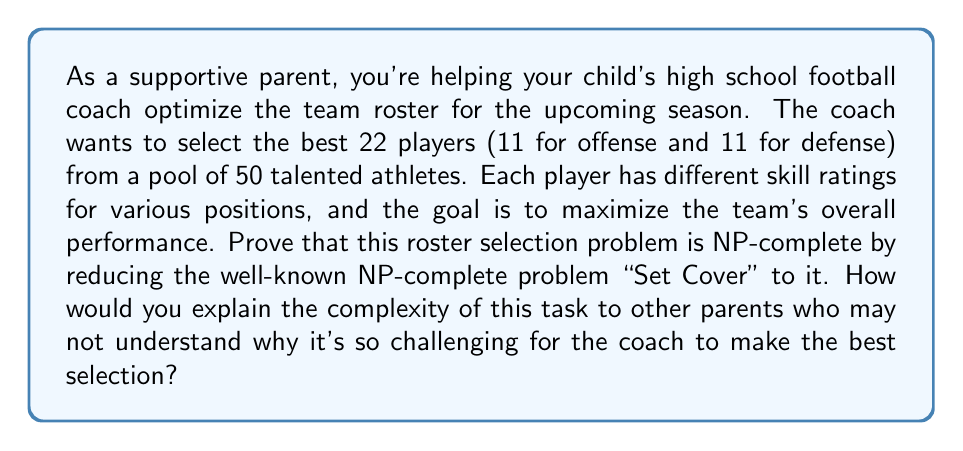Show me your answer to this math problem. To prove that the roster selection problem is NP-complete, we need to show that it's in NP and that a known NP-complete problem can be reduced to it. Let's break this down step-by-step:

1. Show that the problem is in NP:
   A problem is in NP if a proposed solution can be verified in polynomial time. In this case, given a roster selection, we can quickly check if it satisfies all constraints (22 players, 11 for offense and 11 for defense) and calculate the team's overall performance based on the players' skill ratings. This verification can be done in polynomial time.

2. Reduce the Set Cover problem to the roster selection problem:
   The Set Cover problem is known to be NP-complete. We'll show that any instance of Set Cover can be transformed into an instance of the roster selection problem.

   Set Cover problem: Given a universe $U = \{1, 2, ..., n\}$ and a collection of subsets $S = \{S_1, S_2, ..., S_m\}$ of $U$, find the minimum number of subsets from $S$ that cover all elements in $U$.

   Transformation:
   - For each element $i$ in $U$, create a "skill" that needs to be covered.
   - For each subset $S_j$ in $S$, create a player with skill ratings corresponding to the elements it covers.
   - Set the number of players to be selected to $k$ (the target number of subsets in Set Cover).
   - The goal is to select $k$ players that cover all skills (elements of $U$).

3. Proving the reduction:
   - If there exists a solution to the Set Cover problem using $k$ subsets, then there exists a roster selection of $k$ players that covers all skills.
   - Conversely, if there exists a roster selection of $k$ players covering all skills, then there exists a solution to the Set Cover problem using $k$ subsets.

4. Complexity explanation for parents:
   The complexity of this task can be explained to other parents using an analogy:
   Imagine trying to assemble the perfect potluck dinner where each dish must be present, but each parent can bring multiple dishes. The challenge is to invite the minimum number of parents while ensuring all dishes are covered. As the number of dishes and parents increases, the number of possible combinations grows exponentially, making it extremely difficult to find the optimal solution quickly.

   Similarly, in football roster selection, each player can cover multiple positions or skills, and we need to ensure all required skills are covered while selecting the best overall team. The number of possible combinations grows exponentially with the number of players and positions, making it computationally challenging to find the optimal solution quickly.

This reduction proves that the roster selection problem is at least as hard as the Set Cover problem, which is known to be NP-complete. Therefore, the roster selection problem is also NP-complete.
Answer: The roster selection problem is NP-complete. This is proven by showing that the problem is in NP and by reducing the known NP-complete Set Cover problem to it. The complexity can be explained to parents using the potluck dinner analogy, illustrating the exponential growth of possible combinations as the number of players and positions increases. 